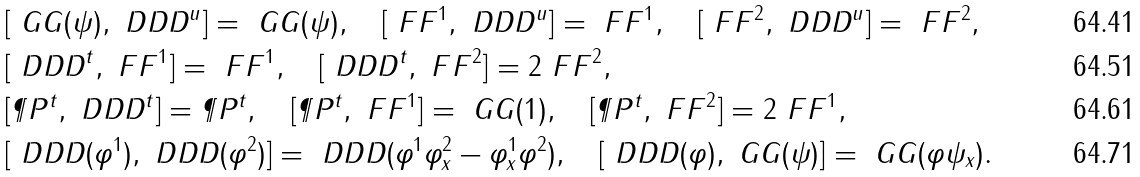<formula> <loc_0><loc_0><loc_500><loc_500>& [ \ G G ( \psi ) , \ D D D ^ { u } ] = \ G G ( \psi ) , \quad [ \ F F ^ { 1 } , \ D D D ^ { u } ] = \ F F ^ { 1 } , \quad [ \ F F ^ { 2 } , \ D D D ^ { u } ] = \ F F ^ { 2 } , \\ & [ \ D D D ^ { t } , \ F F ^ { 1 } ] = \ F F ^ { 1 } , \quad [ \ D D D ^ { t } , \ F F ^ { 2 } ] = 2 \ F F ^ { 2 } , \\ & [ \P P ^ { t } , \ D D D ^ { t } ] = \P P ^ { t } , \quad [ \P P ^ { t } , \ F F ^ { 1 } ] = \ G G ( 1 ) , \quad [ \P P ^ { t } , \ F F ^ { 2 } ] = 2 \ F F ^ { 1 } , \\ & [ \ D D D ( \varphi ^ { 1 } ) , \ D D D ( \varphi ^ { 2 } ) ] = \ D D D ( \varphi ^ { 1 } \varphi ^ { 2 } _ { x } - \varphi ^ { 1 } _ { x } \varphi ^ { 2 } ) , \quad [ \ D D D ( \varphi ) , \ G G ( \psi ) ] = \ G G ( \varphi \psi _ { x } ) .</formula> 